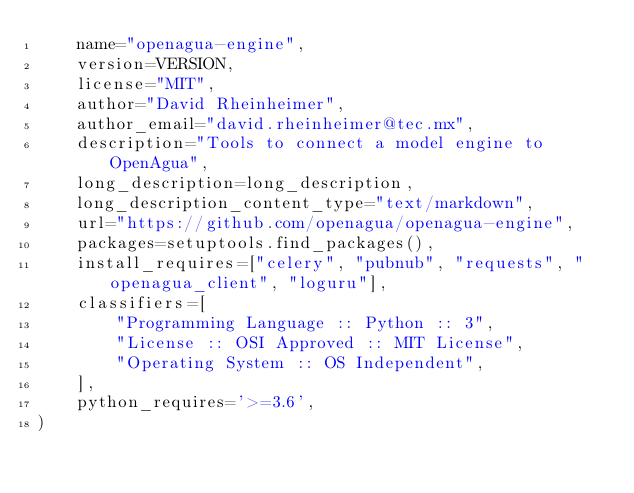Convert code to text. <code><loc_0><loc_0><loc_500><loc_500><_Python_>    name="openagua-engine",
    version=VERSION,
    license="MIT",
    author="David Rheinheimer",
    author_email="david.rheinheimer@tec.mx",
    description="Tools to connect a model engine to OpenAgua",
    long_description=long_description,
    long_description_content_type="text/markdown",
    url="https://github.com/openagua/openagua-engine",
    packages=setuptools.find_packages(),
    install_requires=["celery", "pubnub", "requests", "openagua_client", "loguru"],
    classifiers=[
        "Programming Language :: Python :: 3",
        "License :: OSI Approved :: MIT License",
        "Operating System :: OS Independent",
    ],
    python_requires='>=3.6',
)
</code> 